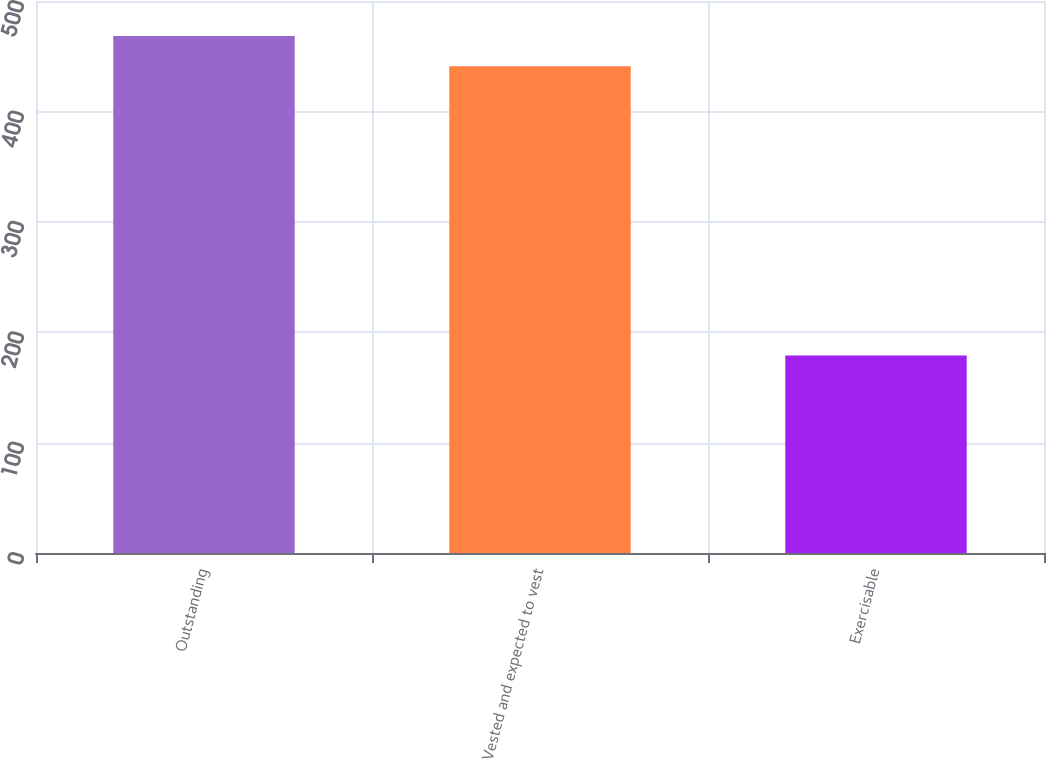<chart> <loc_0><loc_0><loc_500><loc_500><bar_chart><fcel>Outstanding<fcel>Vested and expected to vest<fcel>Exercisable<nl><fcel>468.2<fcel>441<fcel>179<nl></chart> 